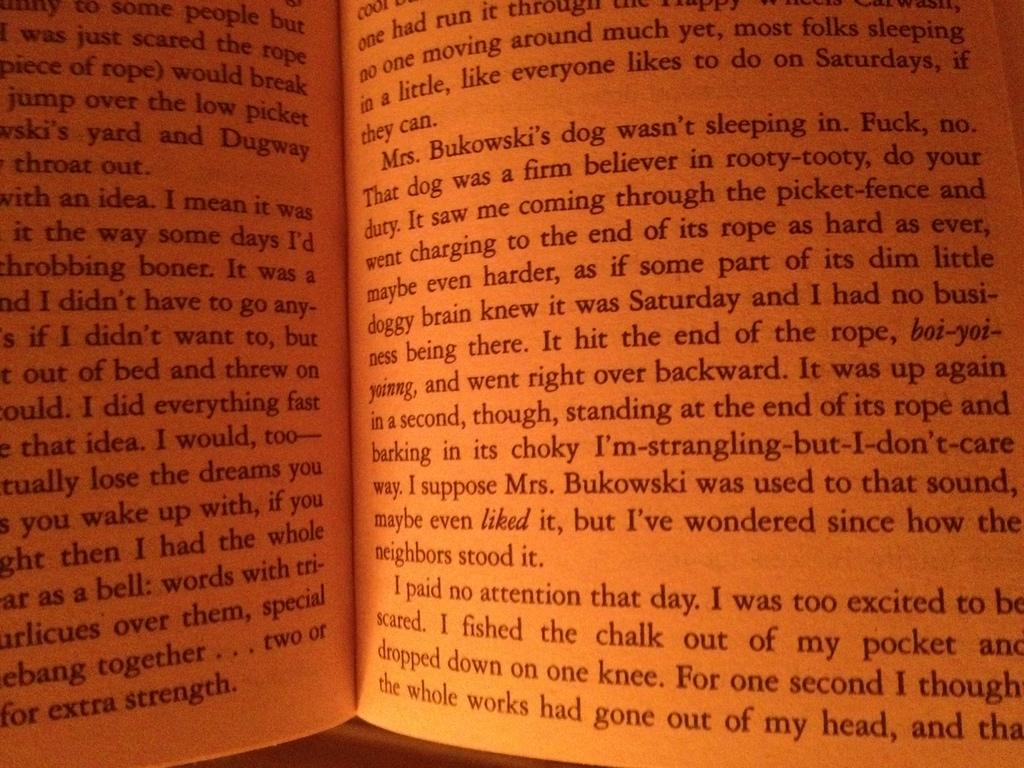Whos dog are they talking about?
Your answer should be very brief. Mrs. bukowski's. 